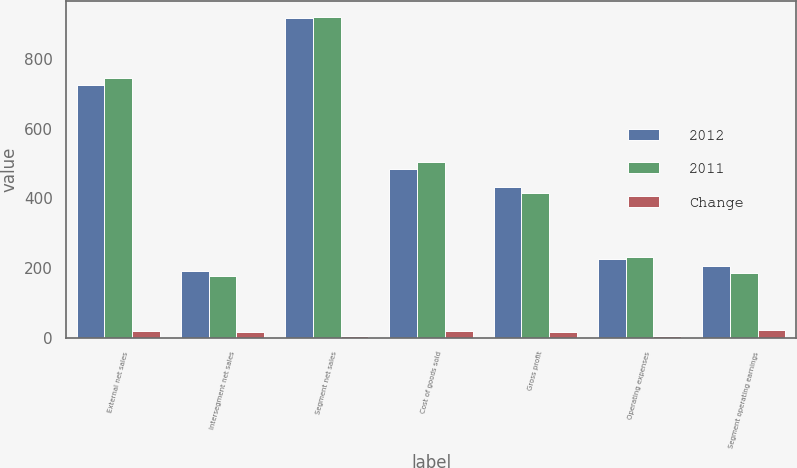<chart> <loc_0><loc_0><loc_500><loc_500><stacked_bar_chart><ecel><fcel>External net sales<fcel>Intersegment net sales<fcel>Segment net sales<fcel>Cost of goods sold<fcel>Gross profit<fcel>Operating expenses<fcel>Segment operating earnings<nl><fcel>2012<fcel>725.3<fcel>191.8<fcel>917.1<fcel>485.2<fcel>431.9<fcel>226.2<fcel>205.7<nl><fcel>2011<fcel>744.9<fcel>175.7<fcel>920.6<fcel>504.3<fcel>416.3<fcel>231.6<fcel>184.7<nl><fcel>Change<fcel>19.6<fcel>16.1<fcel>3.5<fcel>19.1<fcel>15.6<fcel>5.4<fcel>21<nl></chart> 